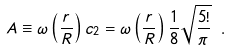Convert formula to latex. <formula><loc_0><loc_0><loc_500><loc_500>A \equiv \omega \left ( \frac { r } { R } \right ) c _ { 2 } = \omega \left ( \frac { r } { R } \right ) \frac { 1 } { 8 } \sqrt { \frac { 5 ! } { \pi } } \ .</formula> 